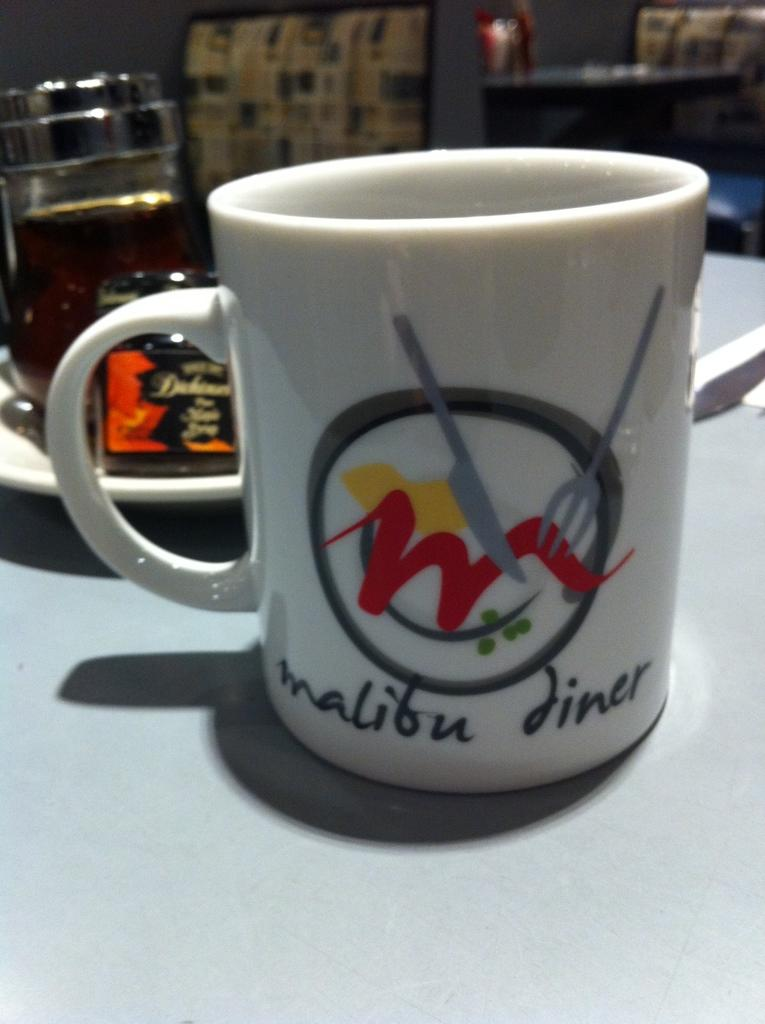<image>
Offer a succinct explanation of the picture presented. table with a malibu diner mug on it and a plate and utensils behind it 